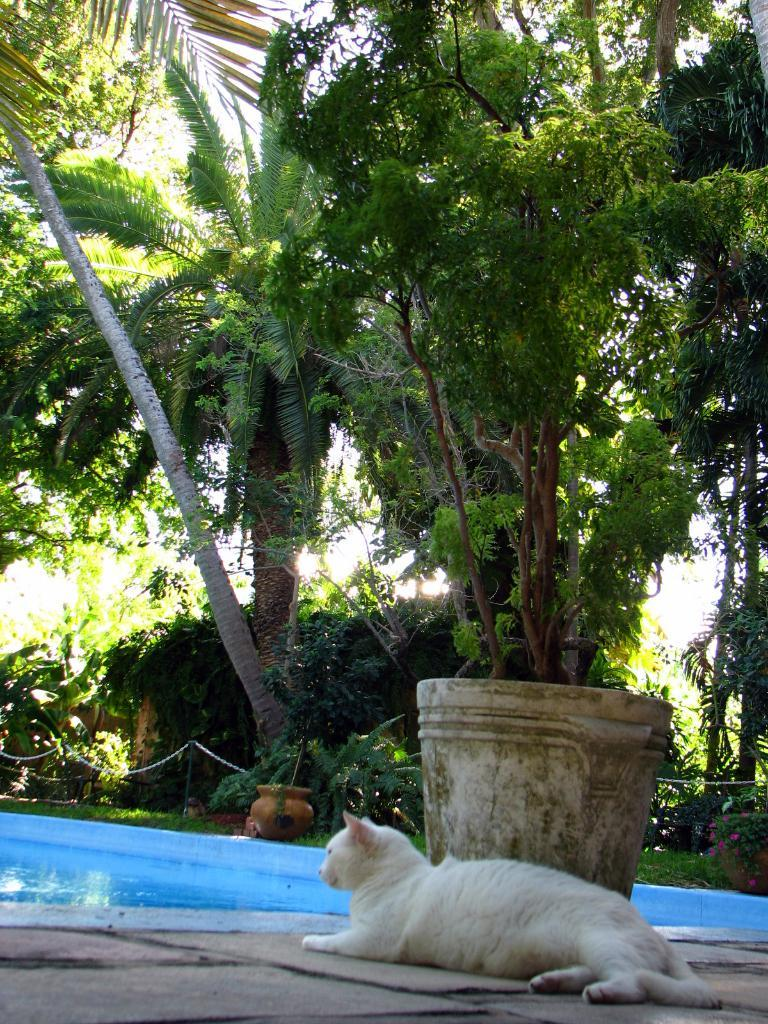What animal is lying on the ground in the image? There is a cat lying on the ground in the image. Where is the cat located in relation to the swimming pool? The cat is near a swimming pool in the image. What type of vegetation can be seen in the image? There are plants in pots and trees visible in the image. What type of note is the cat holding in the image? There is no note present in the image, and the cat is not holding anything. 